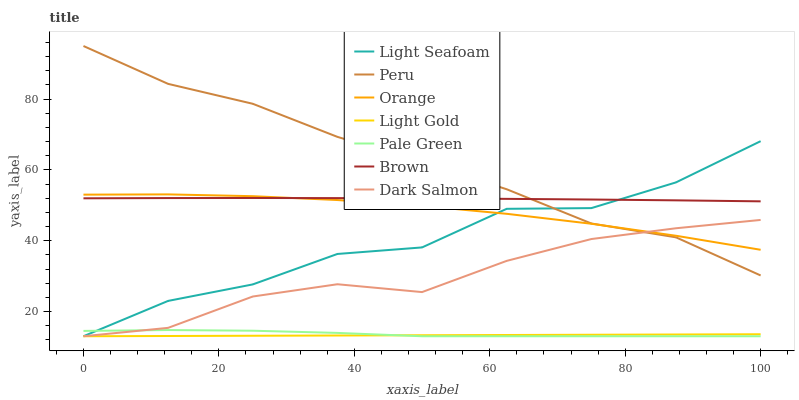Does Light Gold have the minimum area under the curve?
Answer yes or no. Yes. Does Peru have the maximum area under the curve?
Answer yes or no. Yes. Does Dark Salmon have the minimum area under the curve?
Answer yes or no. No. Does Dark Salmon have the maximum area under the curve?
Answer yes or no. No. Is Light Gold the smoothest?
Answer yes or no. Yes. Is Light Seafoam the roughest?
Answer yes or no. Yes. Is Dark Salmon the smoothest?
Answer yes or no. No. Is Dark Salmon the roughest?
Answer yes or no. No. Does Dark Salmon have the lowest value?
Answer yes or no. Yes. Does Peru have the lowest value?
Answer yes or no. No. Does Peru have the highest value?
Answer yes or no. Yes. Does Dark Salmon have the highest value?
Answer yes or no. No. Is Light Gold less than Orange?
Answer yes or no. Yes. Is Orange greater than Pale Green?
Answer yes or no. Yes. Does Light Seafoam intersect Light Gold?
Answer yes or no. Yes. Is Light Seafoam less than Light Gold?
Answer yes or no. No. Is Light Seafoam greater than Light Gold?
Answer yes or no. No. Does Light Gold intersect Orange?
Answer yes or no. No. 